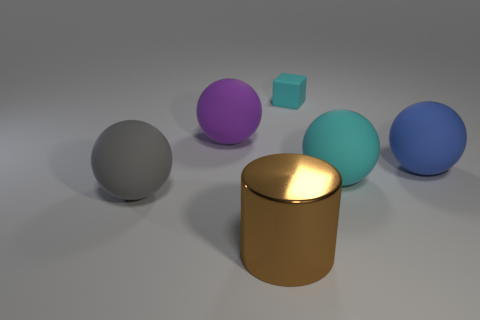There is a purple object that is the same size as the blue matte sphere; what is its shape?
Give a very brief answer. Sphere. What number of other things are there of the same color as the cube?
Keep it short and to the point. 1. What is the color of the object that is in front of the big gray rubber ball?
Provide a succinct answer. Brown. How many other things are there of the same material as the gray thing?
Give a very brief answer. 4. Are there more big brown objects right of the gray thing than tiny things in front of the big cyan thing?
Ensure brevity in your answer.  Yes. What number of things are on the left side of the brown metallic cylinder?
Offer a terse response. 2. Is the large blue thing made of the same material as the large thing that is in front of the large gray rubber object?
Make the answer very short. No. Are there any other things that have the same shape as the small matte object?
Ensure brevity in your answer.  No. Do the cube and the brown cylinder have the same material?
Keep it short and to the point. No. There is a large object behind the large blue rubber ball; is there a big purple rubber ball right of it?
Offer a very short reply. No. 